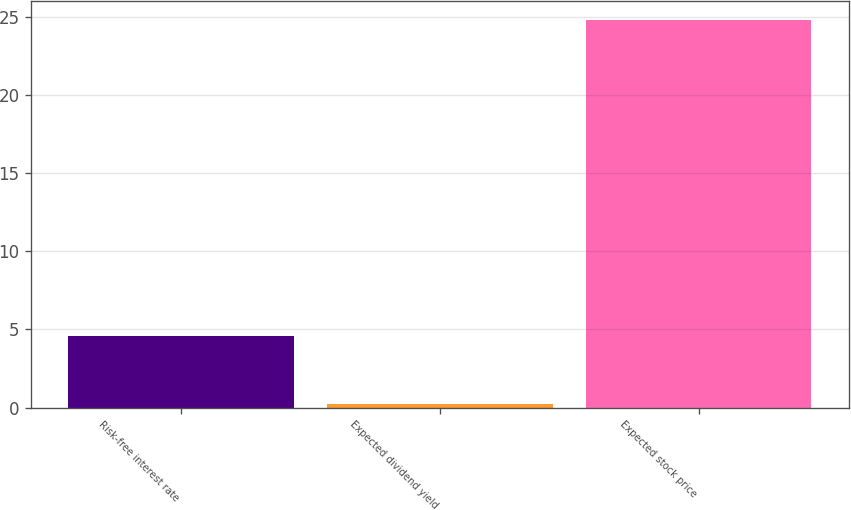Convert chart. <chart><loc_0><loc_0><loc_500><loc_500><bar_chart><fcel>Risk-free interest rate<fcel>Expected dividend yield<fcel>Expected stock price<nl><fcel>4.6<fcel>0.2<fcel>24.8<nl></chart> 